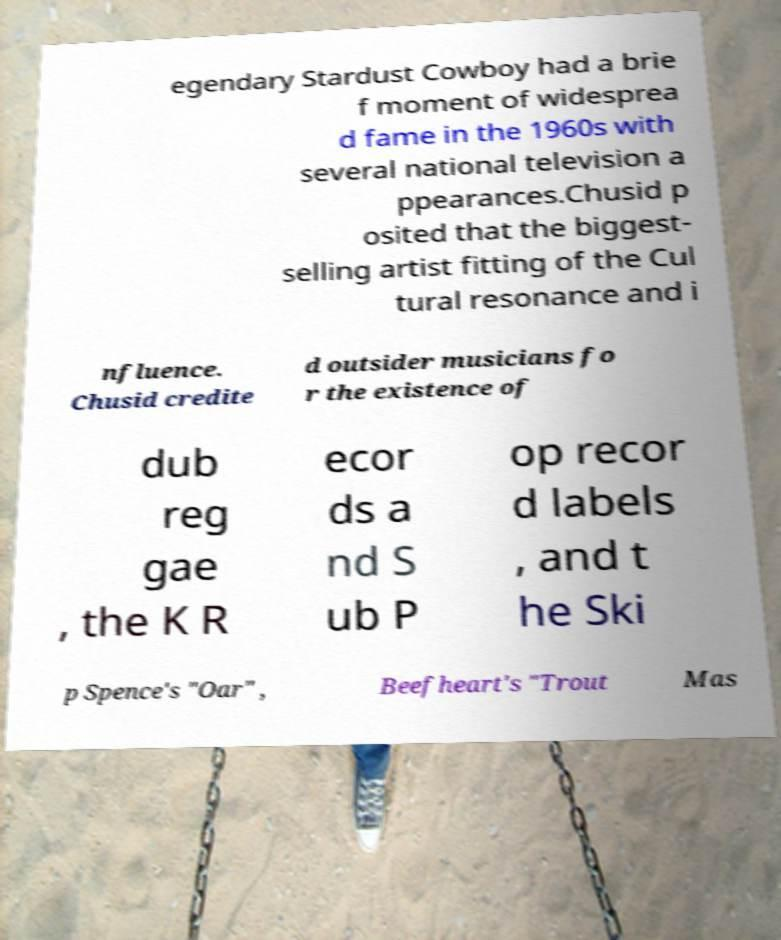Please identify and transcribe the text found in this image. egendary Stardust Cowboy had a brie f moment of widesprea d fame in the 1960s with several national television a ppearances.Chusid p osited that the biggest- selling artist fitting of the Cul tural resonance and i nfluence. Chusid credite d outsider musicians fo r the existence of dub reg gae , the K R ecor ds a nd S ub P op recor d labels , and t he Ski p Spence's "Oar" , Beefheart's "Trout Mas 